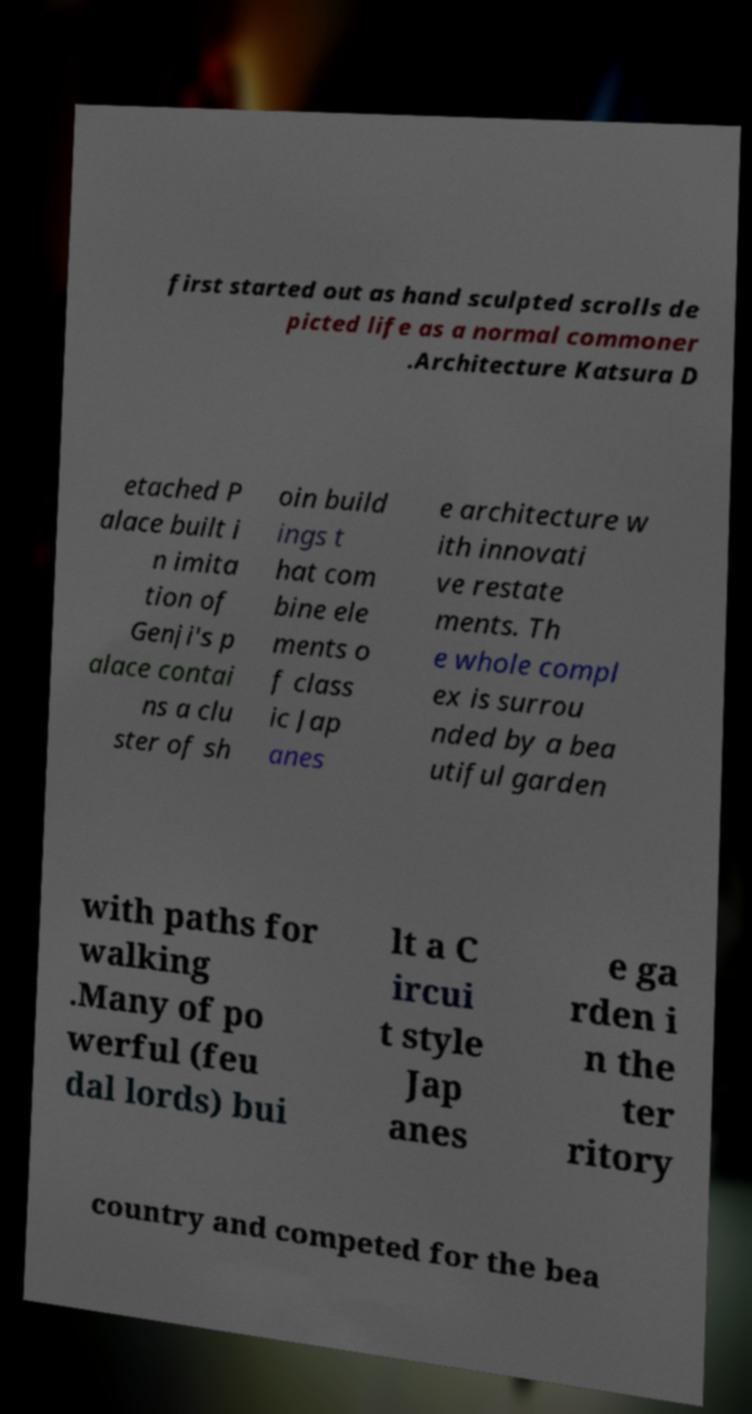For documentation purposes, I need the text within this image transcribed. Could you provide that? first started out as hand sculpted scrolls de picted life as a normal commoner .Architecture Katsura D etached P alace built i n imita tion of Genji's p alace contai ns a clu ster of sh oin build ings t hat com bine ele ments o f class ic Jap anes e architecture w ith innovati ve restate ments. Th e whole compl ex is surrou nded by a bea utiful garden with paths for walking .Many of po werful (feu dal lords) bui lt a C ircui t style Jap anes e ga rden i n the ter ritory country and competed for the bea 